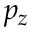Convert formula to latex. <formula><loc_0><loc_0><loc_500><loc_500>p _ { z }</formula> 